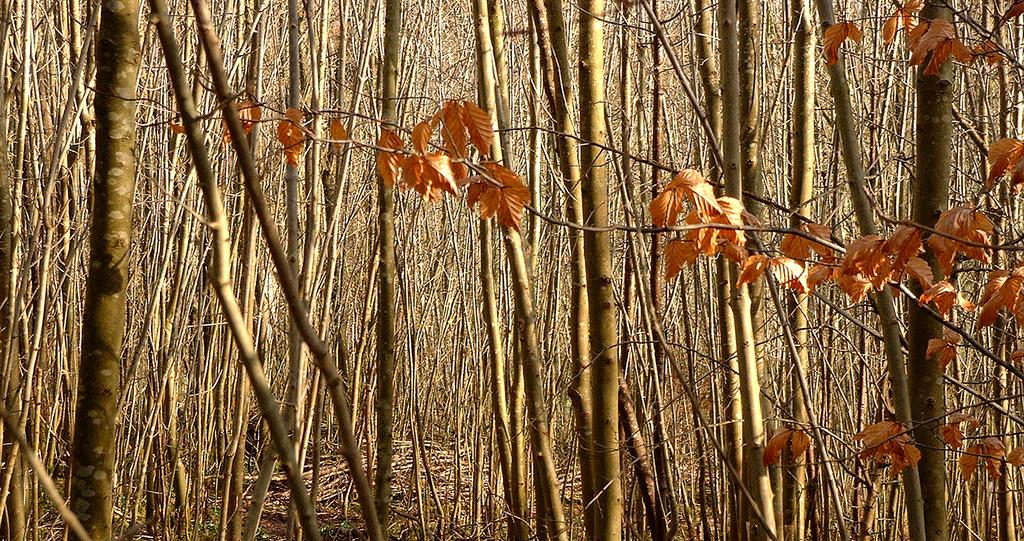What type of vegetation can be seen in the image? There are trees in the image. What can be found on the trees? There are leaves on the trees. What is the profit margin of the tramp in the image? There is no tramp present in the image, so it is not possible to determine the profit margin. 